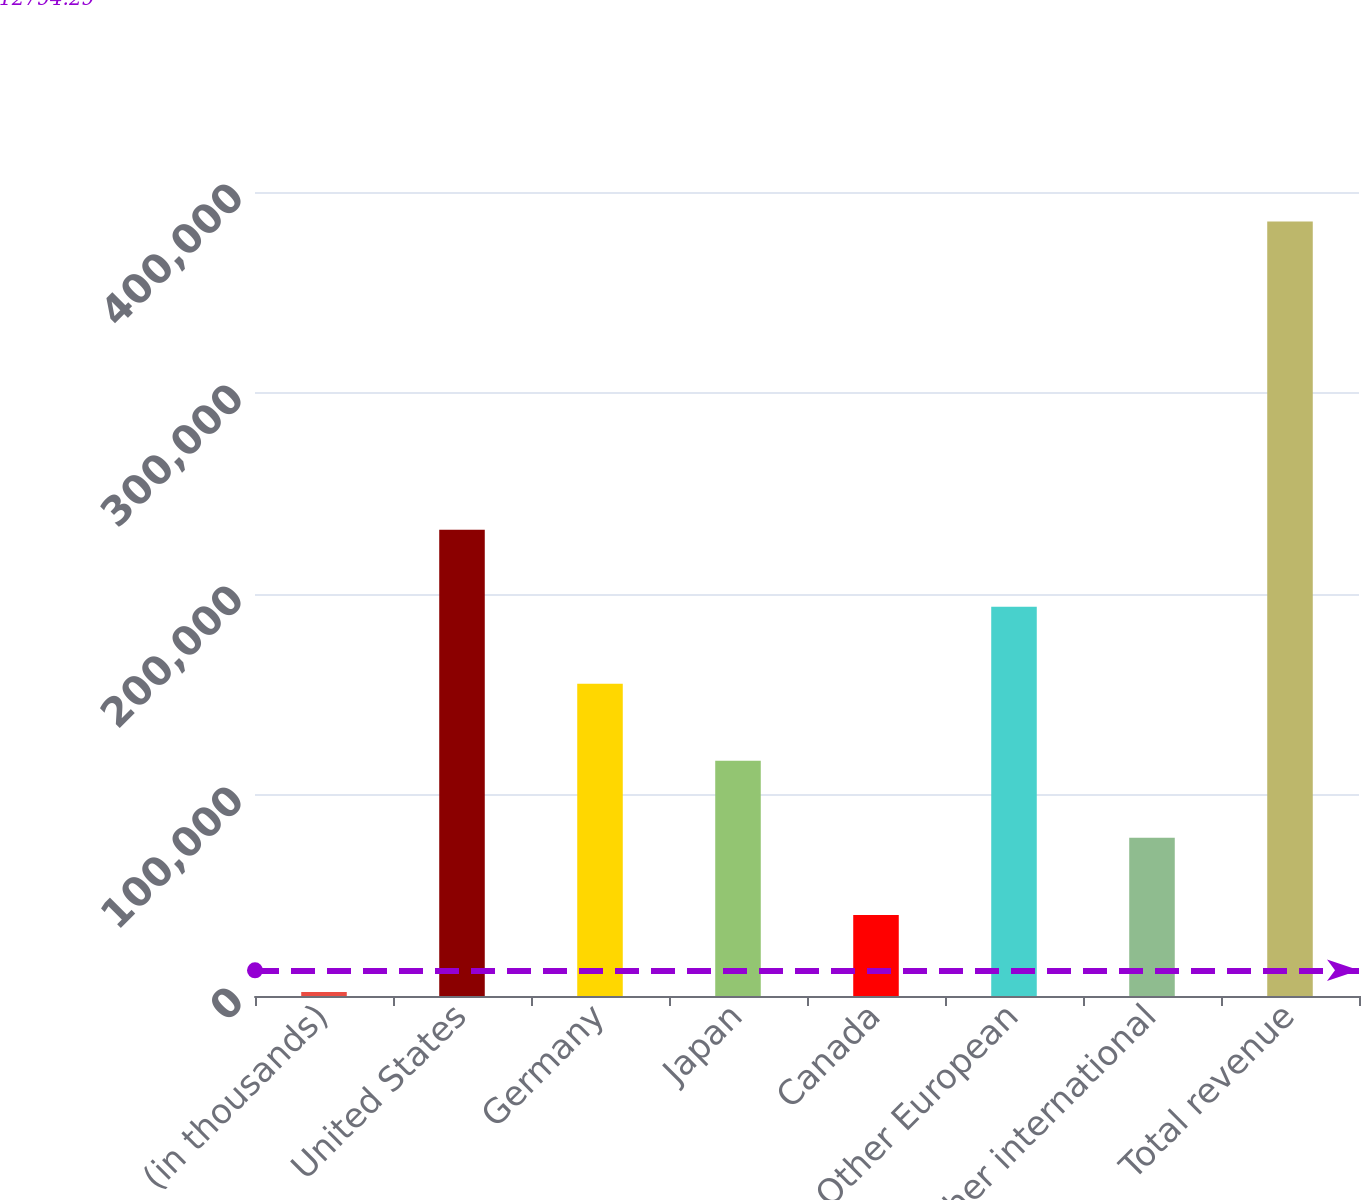Convert chart. <chart><loc_0><loc_0><loc_500><loc_500><bar_chart><fcel>(in thousands)<fcel>United States<fcel>Germany<fcel>Japan<fcel>Canada<fcel>Other European<fcel>Other international<fcel>Total revenue<nl><fcel>2007<fcel>232007<fcel>155340<fcel>117007<fcel>40340.3<fcel>193674<fcel>78673.6<fcel>385340<nl></chart> 